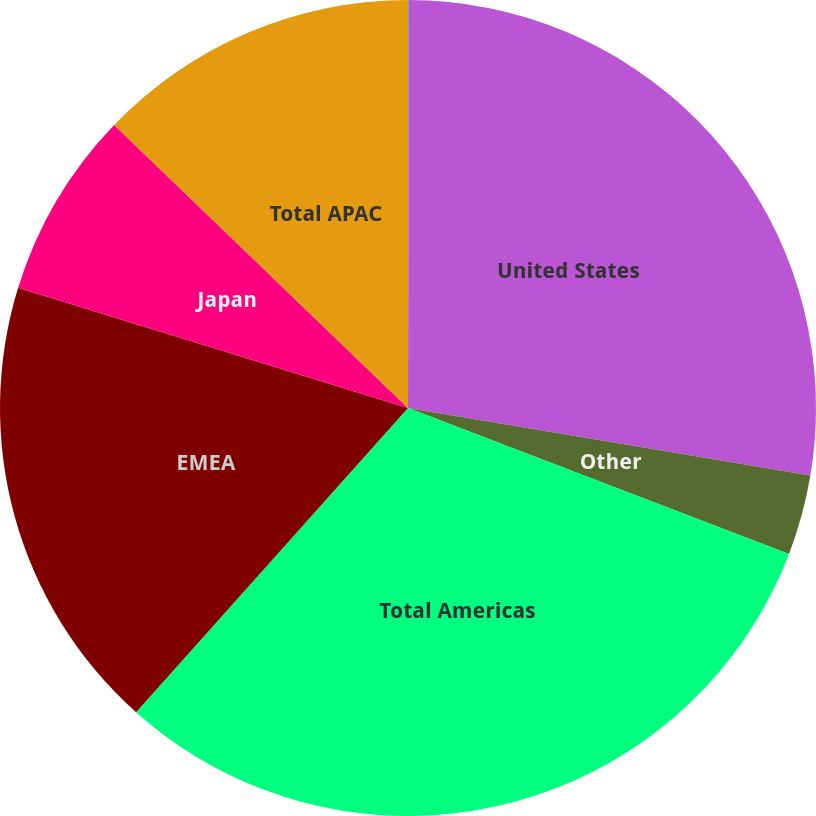Convert chart to OTSL. <chart><loc_0><loc_0><loc_500><loc_500><pie_chart><fcel>Revenue<fcel>United States<fcel>Other<fcel>Total Americas<fcel>EMEA<fcel>Japan<fcel>Total APAC<nl><fcel>0.03%<fcel>27.62%<fcel>3.17%<fcel>30.79%<fcel>18.15%<fcel>7.44%<fcel>12.8%<nl></chart> 